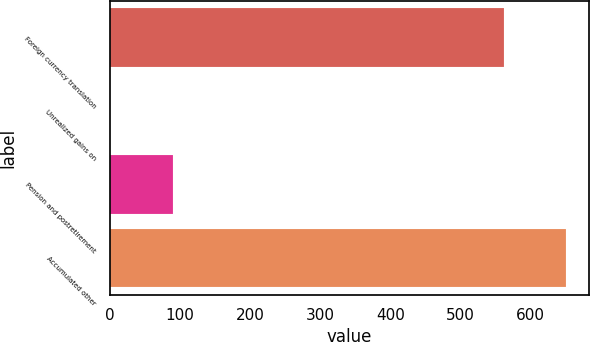<chart> <loc_0><loc_0><loc_500><loc_500><bar_chart><fcel>Foreign currency translation<fcel>Unrealized gains on<fcel>Pension and postretirement<fcel>Accumulated other<nl><fcel>561.4<fcel>0.3<fcel>89.7<fcel>650.8<nl></chart> 